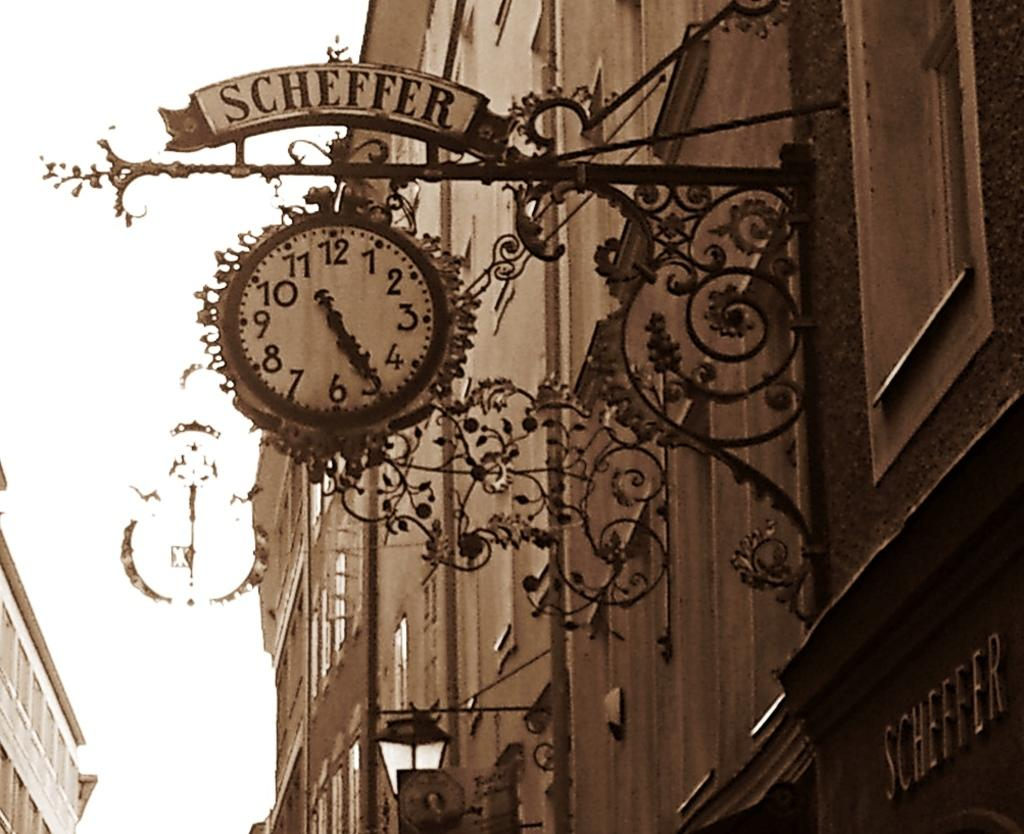<image>
Give a short and clear explanation of the subsequent image. Front of a buliding with a clock that says Scheffer. 